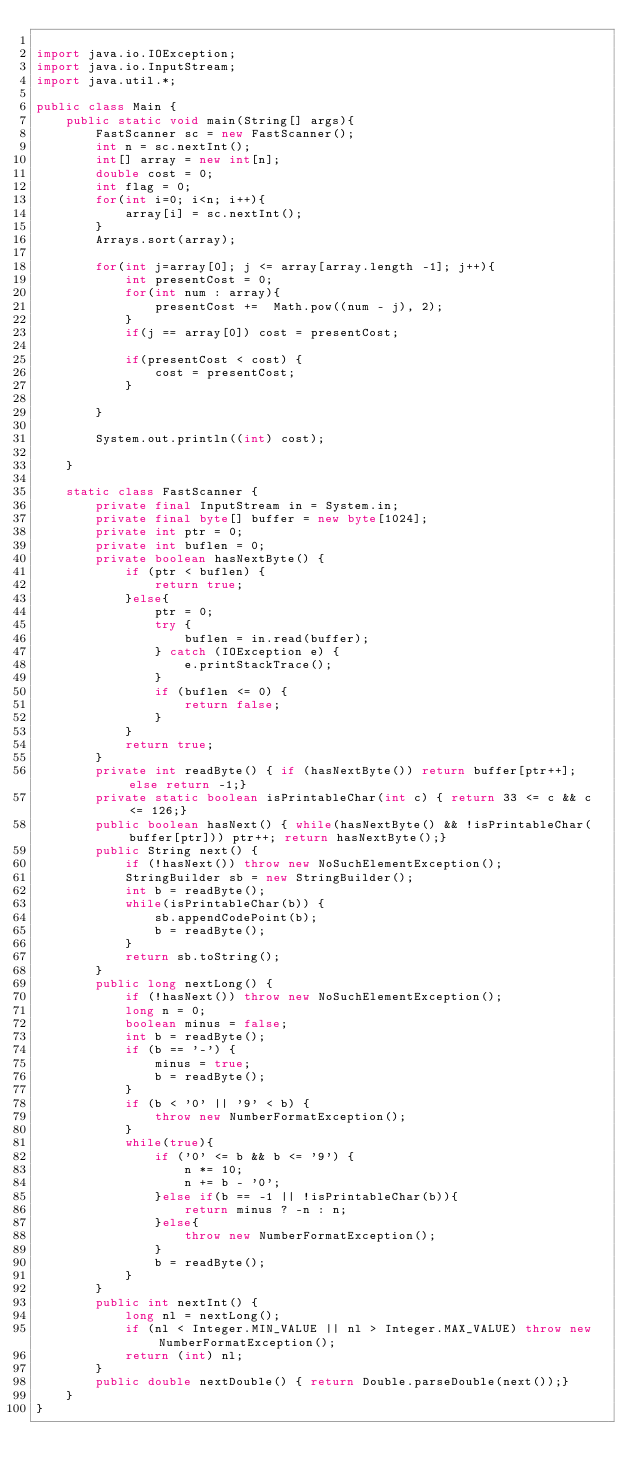<code> <loc_0><loc_0><loc_500><loc_500><_Java_>
import java.io.IOException;
import java.io.InputStream;
import java.util.*;

public class Main {
    public static void main(String[] args){
        FastScanner sc = new FastScanner();
        int n = sc.nextInt();
        int[] array = new int[n];
        double cost = 0;
        int flag = 0;
        for(int i=0; i<n; i++){
            array[i] = sc.nextInt();
        }
        Arrays.sort(array);

        for(int j=array[0]; j <= array[array.length -1]; j++){
            int presentCost = 0;
            for(int num : array){
                presentCost +=  Math.pow((num - j), 2);
            }
            if(j == array[0]) cost = presentCost;

            if(presentCost < cost) {
                cost = presentCost;
            }

        }

        System.out.println((int) cost);

    }

    static class FastScanner {
        private final InputStream in = System.in;
        private final byte[] buffer = new byte[1024];
        private int ptr = 0;
        private int buflen = 0;
        private boolean hasNextByte() {
            if (ptr < buflen) {
                return true;
            }else{
                ptr = 0;
                try {
                    buflen = in.read(buffer);
                } catch (IOException e) {
                    e.printStackTrace();
                }
                if (buflen <= 0) {
                    return false;
                }
            }
            return true;
        }
        private int readByte() { if (hasNextByte()) return buffer[ptr++]; else return -1;}
        private static boolean isPrintableChar(int c) { return 33 <= c && c <= 126;}
        public boolean hasNext() { while(hasNextByte() && !isPrintableChar(buffer[ptr])) ptr++; return hasNextByte();}
        public String next() {
            if (!hasNext()) throw new NoSuchElementException();
            StringBuilder sb = new StringBuilder();
            int b = readByte();
            while(isPrintableChar(b)) {
                sb.appendCodePoint(b);
                b = readByte();
            }
            return sb.toString();
        }
        public long nextLong() {
            if (!hasNext()) throw new NoSuchElementException();
            long n = 0;
            boolean minus = false;
            int b = readByte();
            if (b == '-') {
                minus = true;
                b = readByte();
            }
            if (b < '0' || '9' < b) {
                throw new NumberFormatException();
            }
            while(true){
                if ('0' <= b && b <= '9') {
                    n *= 10;
                    n += b - '0';
                }else if(b == -1 || !isPrintableChar(b)){
                    return minus ? -n : n;
                }else{
                    throw new NumberFormatException();
                }
                b = readByte();
            }
        }
        public int nextInt() {
            long nl = nextLong();
            if (nl < Integer.MIN_VALUE || nl > Integer.MAX_VALUE) throw new NumberFormatException();
            return (int) nl;
        }
        public double nextDouble() { return Double.parseDouble(next());}
    }
}
</code> 